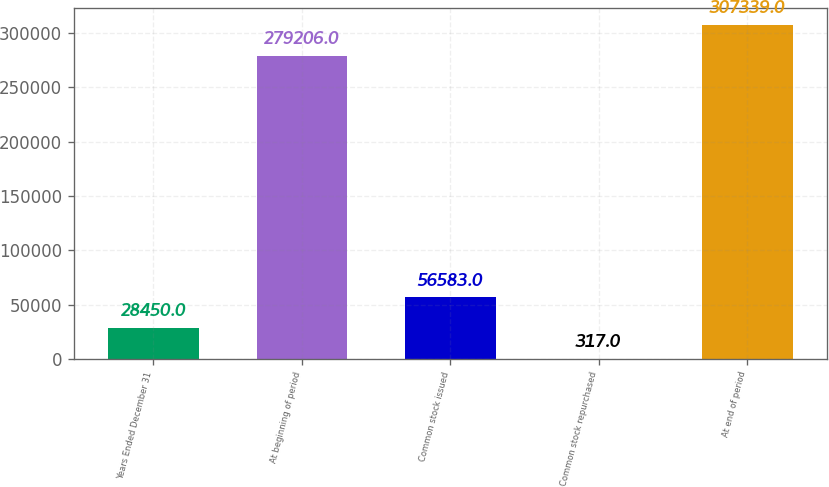<chart> <loc_0><loc_0><loc_500><loc_500><bar_chart><fcel>Years Ended December 31<fcel>At beginning of period<fcel>Common stock issued<fcel>Common stock repurchased<fcel>At end of period<nl><fcel>28450<fcel>279206<fcel>56583<fcel>317<fcel>307339<nl></chart> 